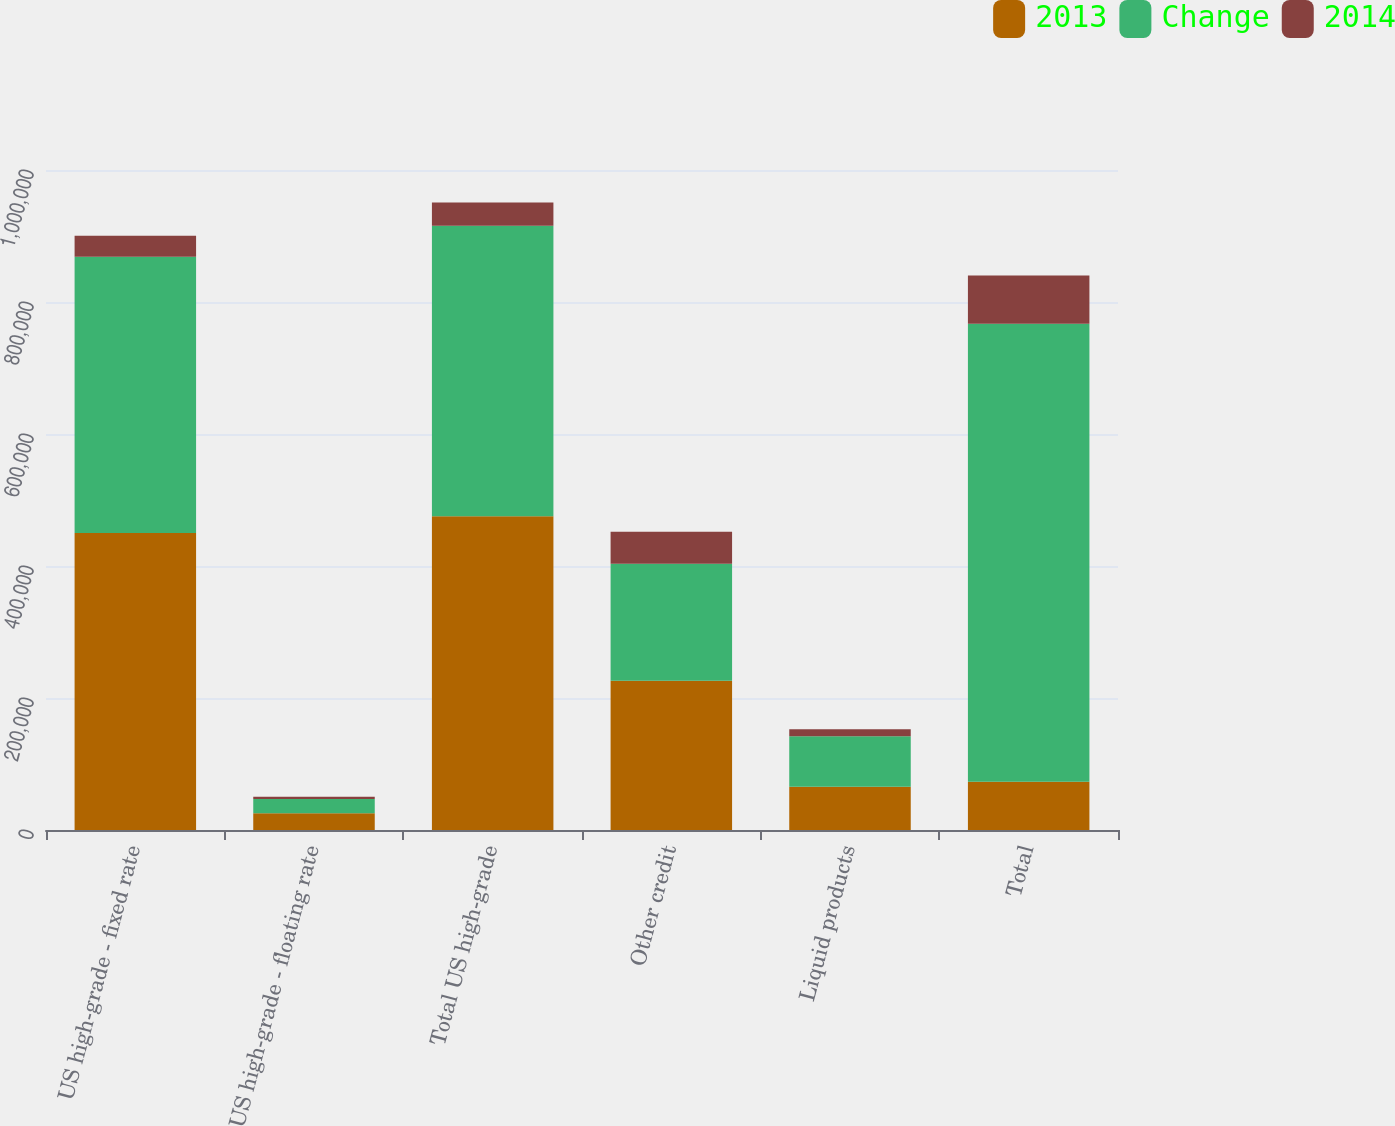Convert chart to OTSL. <chart><loc_0><loc_0><loc_500><loc_500><stacked_bar_chart><ecel><fcel>US high-grade - fixed rate<fcel>US high-grade - floating rate<fcel>Total US high-grade<fcel>Other credit<fcel>Liquid products<fcel>Total<nl><fcel>2013<fcel>450139<fcel>25231<fcel>475370<fcel>226033<fcel>65558<fcel>73285<nl><fcel>Change<fcel>418270<fcel>21813<fcel>440083<fcel>177274<fcel>76319<fcel>693676<nl><fcel>2014<fcel>31869<fcel>3418<fcel>35287<fcel>48759<fcel>10761<fcel>73285<nl></chart> 